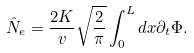Convert formula to latex. <formula><loc_0><loc_0><loc_500><loc_500>\hat { N } _ { e } = \frac { 2 K } { v } \sqrt { \frac { 2 } { \pi } } \int _ { 0 } ^ { L } d x \partial _ { t } \Phi .</formula> 